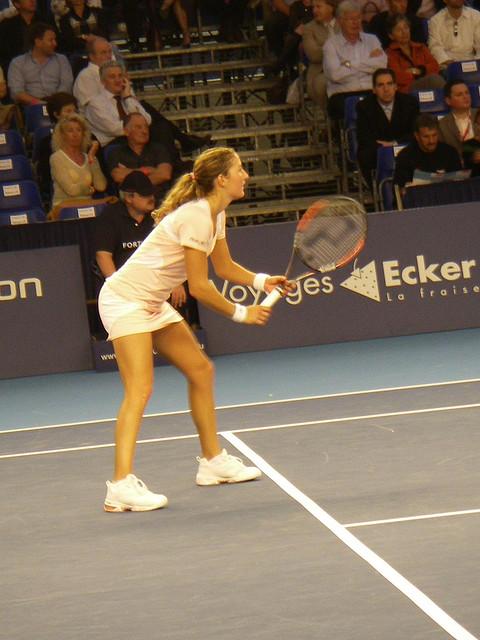What color is the woman skirt?
Give a very brief answer. White. Is someone taking a photo of the player?
Answer briefly. Yes. What is the woman doing?
Give a very brief answer. Playing tennis. What is the man in the first row holding to his face?
Write a very short answer. Paper. Is there a woman in the crowd wearing a see threw shirt?
Be succinct. Yes. How many steps are on the staircase?
Write a very short answer. 8. What is the woman holding?
Quick response, please. Tennis racket. How many times has she hit the ball?
Write a very short answer. 0. Who is that?
Give a very brief answer. Tennis player. 